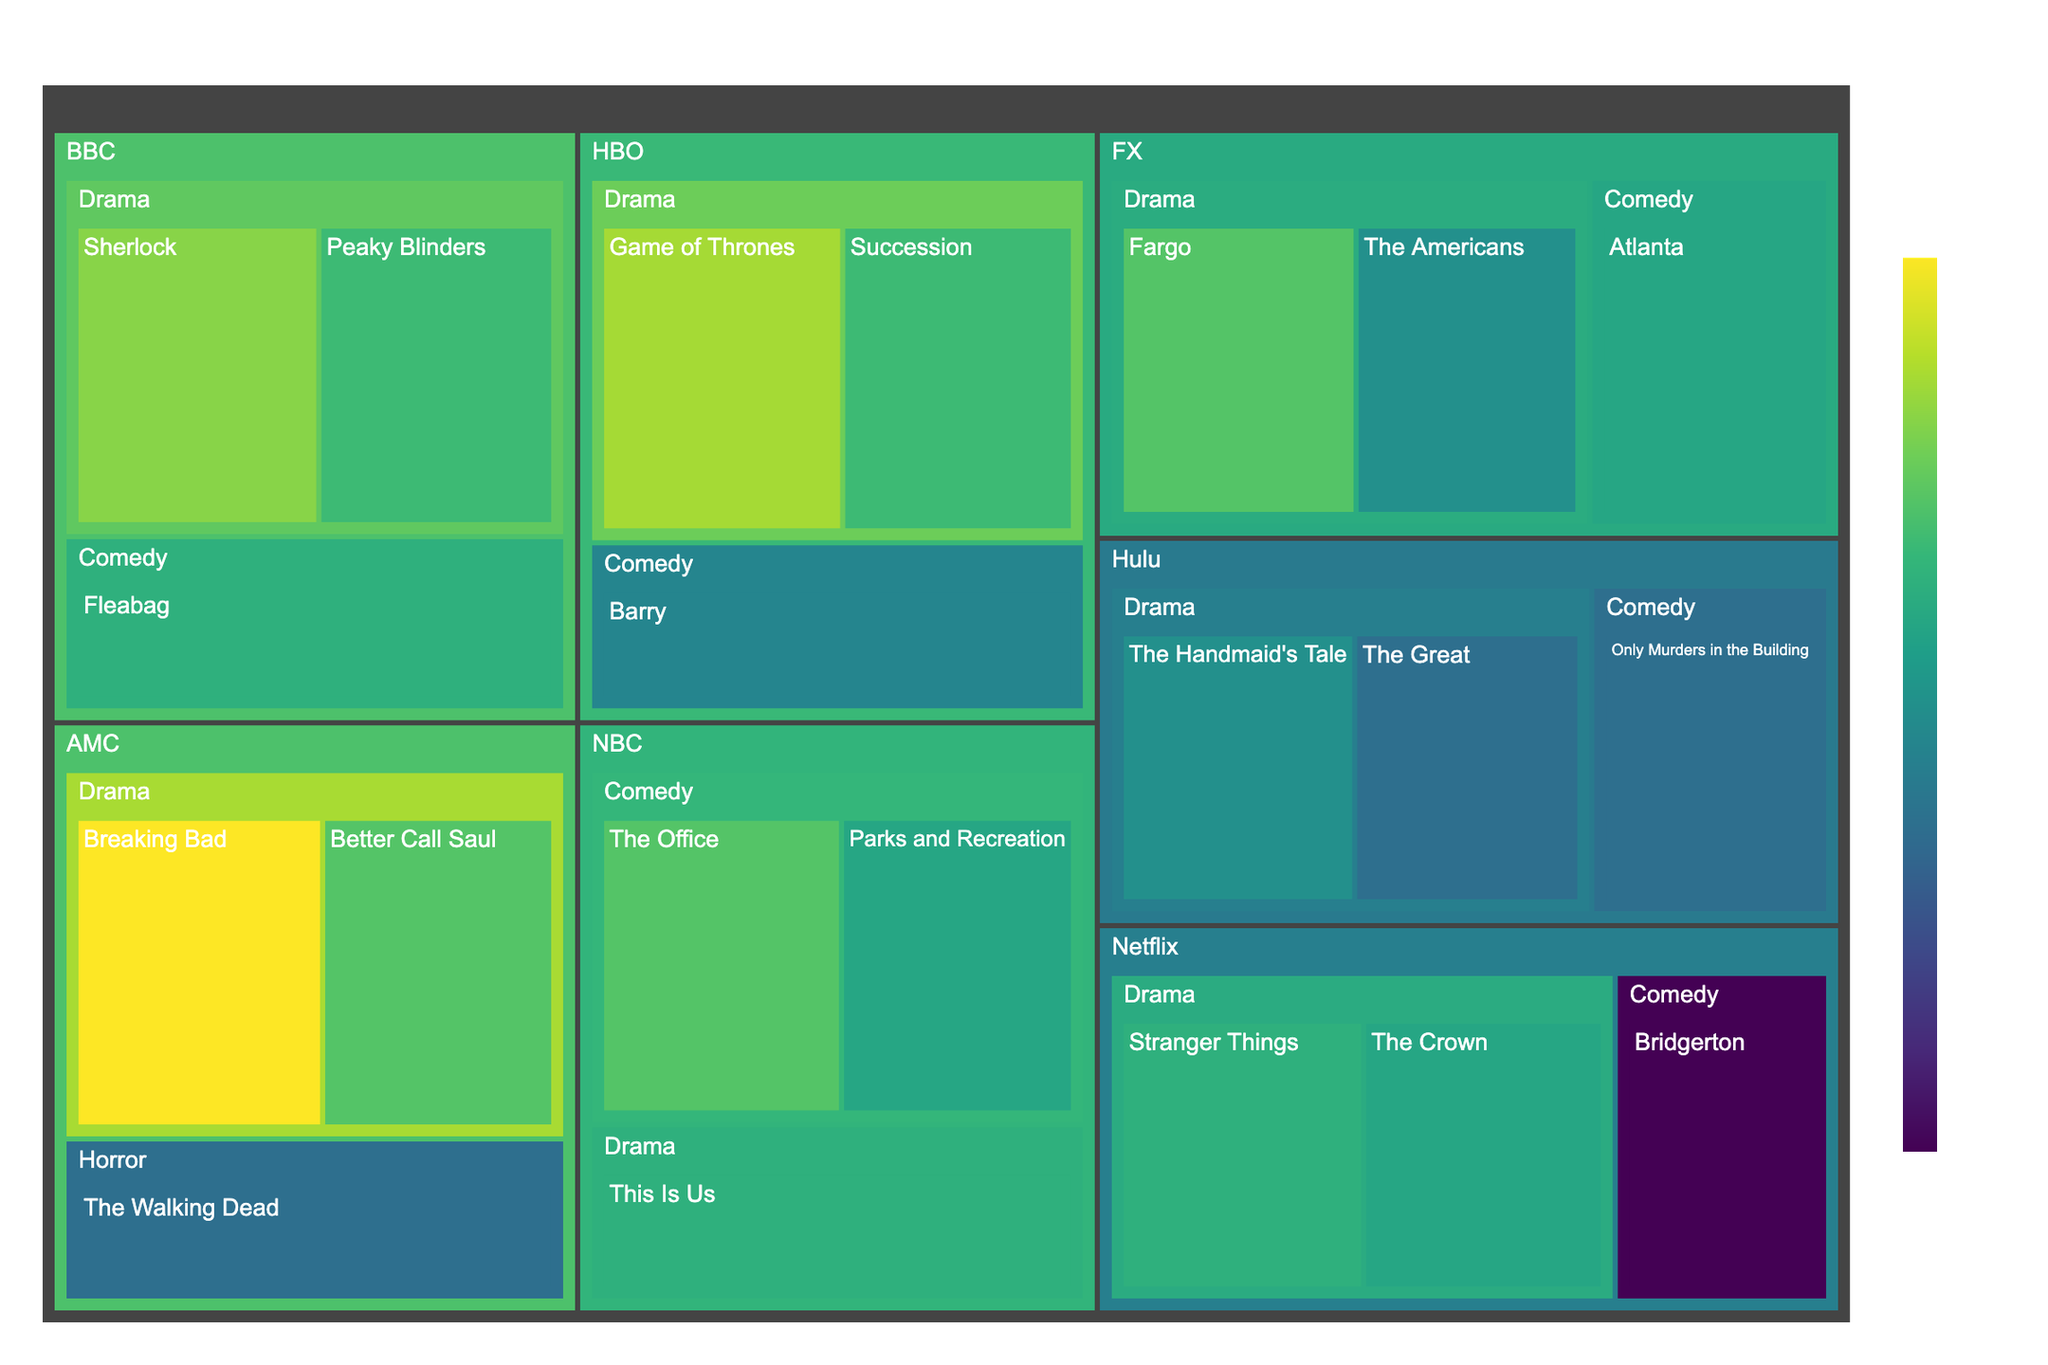Which network has the highest-rated TV series? Look at the highest rating value and identify the network associated with that series. Breaking Bad on AMC has a rating of 9.5, which is the highest.
Answer: AMC Which drama series has the lowest rating? Among the drama series, look for the one with the lowest numerical rating value. The Walking Dead on AMC has a rating of 8.1, which is the lowest for a drama series.
Answer: The Walking Dead How many TV series are there from NBC in the figure? Count the number of TV series nodes under the NBC network section. There are three series: The Office, Parks and Recreation, and This Is Us.
Answer: 3 What is the average rating of the TV series from HBO? Add the ratings of all HBO series and divide by the number of series. (9.2 + 8.8 + 8.3) / 3 = 8.77
Answer: 8.77 Between drama and comedy, which genre has more TV series in total across all networks? Count the number of series under the Drama and Comedy categories and compare. Drama (Game of Thrones, Succession, Stranger Things, The Crown, Breaking Bad, Better Call Saul, The Walking Dead, This Is Us, The Americans, Fargo, Sherlock, Peaky Blinders, The Handmaid's Tale, The Great): 14. Comedy (Barry, Bridgerton, The Office, Parks and Recreation, Atlanta, Fleabag, Only Murders in the Building): 7. Drama has more series.
Answer: Drama Which series from Hulu has the highest rating? Compare the ratings of the TV series under the Hulu section and identify the one with the highest rating. The Handmaid's Tale has the highest rating of 8.4.
Answer: The Handmaid's Tale How does the highest-rated series of FX compare to the highest-rated series of HBO? Identify the highest rating series from both networks and compare their ratings. FX's highest-rated series is Fargo with 8.9, while HBO's highest is Game of Thrones with 9.2.
Answer: FX's highest-rated series (Fargo) has a lower rating (8.9) compared to HBO's highest-rated series (Game of Thrones) with 9.2 What is the total number of TV series from Netflix in the figure? Count the number of series nodes under the Netflix network section. There are three series: Stranger Things, The Crown, and Bridgerton.
Answer: 3 Which series has a higher rating: The Office or Peaky Blinders? Compare the rating values of The Office and Peaky Blinders. The Office has a rating of 8.9, and Peaky Blinders has 8.8.
Answer: The Office How many networks have at least one TV series rated above 9.0? Count the networks that have at least one series with a rating of greater than 9.0. HBO (Game of Thrones), AMC (Breaking Bad), and BBC (Sherlock).
Answer: 3 